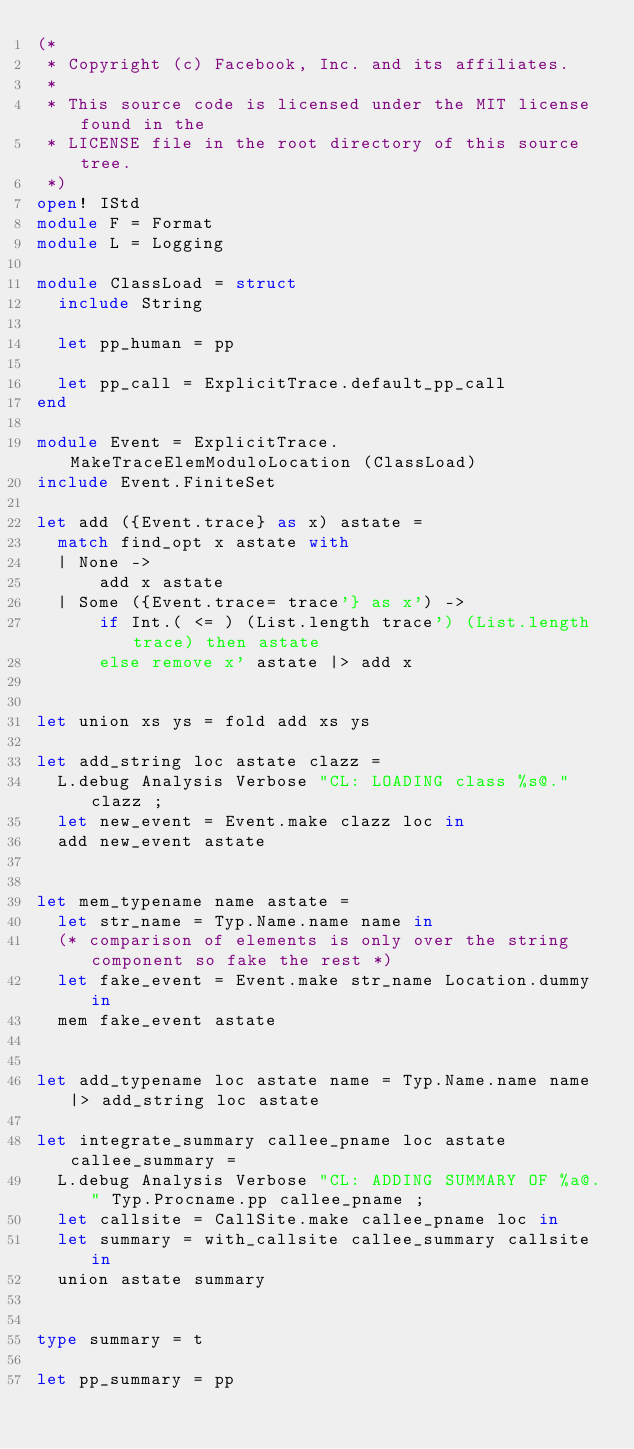<code> <loc_0><loc_0><loc_500><loc_500><_OCaml_>(*
 * Copyright (c) Facebook, Inc. and its affiliates.
 *
 * This source code is licensed under the MIT license found in the
 * LICENSE file in the root directory of this source tree.
 *)
open! IStd
module F = Format
module L = Logging

module ClassLoad = struct
  include String

  let pp_human = pp

  let pp_call = ExplicitTrace.default_pp_call
end

module Event = ExplicitTrace.MakeTraceElemModuloLocation (ClassLoad)
include Event.FiniteSet

let add ({Event.trace} as x) astate =
  match find_opt x astate with
  | None ->
      add x astate
  | Some ({Event.trace= trace'} as x') ->
      if Int.( <= ) (List.length trace') (List.length trace) then astate
      else remove x' astate |> add x


let union xs ys = fold add xs ys

let add_string loc astate clazz =
  L.debug Analysis Verbose "CL: LOADING class %s@." clazz ;
  let new_event = Event.make clazz loc in
  add new_event astate


let mem_typename name astate =
  let str_name = Typ.Name.name name in
  (* comparison of elements is only over the string component so fake the rest *)
  let fake_event = Event.make str_name Location.dummy in
  mem fake_event astate


let add_typename loc astate name = Typ.Name.name name |> add_string loc astate

let integrate_summary callee_pname loc astate callee_summary =
  L.debug Analysis Verbose "CL: ADDING SUMMARY OF %a@." Typ.Procname.pp callee_pname ;
  let callsite = CallSite.make callee_pname loc in
  let summary = with_callsite callee_summary callsite in
  union astate summary


type summary = t

let pp_summary = pp
</code> 